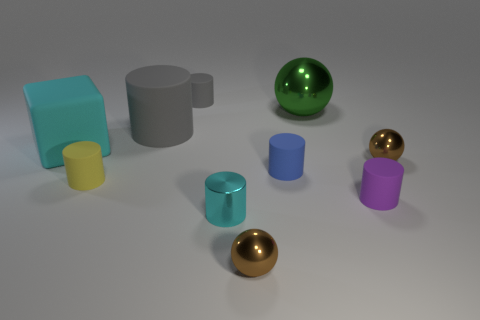Subtract 2 cylinders. How many cylinders are left? 4 Subtract all gray cylinders. How many cylinders are left? 4 Subtract all blue cylinders. How many cylinders are left? 5 Subtract all green balls. Subtract all red cylinders. How many balls are left? 2 Subtract all spheres. How many objects are left? 7 Add 5 metallic spheres. How many metallic spheres exist? 8 Subtract 0 purple balls. How many objects are left? 10 Subtract all large yellow objects. Subtract all big green objects. How many objects are left? 9 Add 4 purple objects. How many purple objects are left? 5 